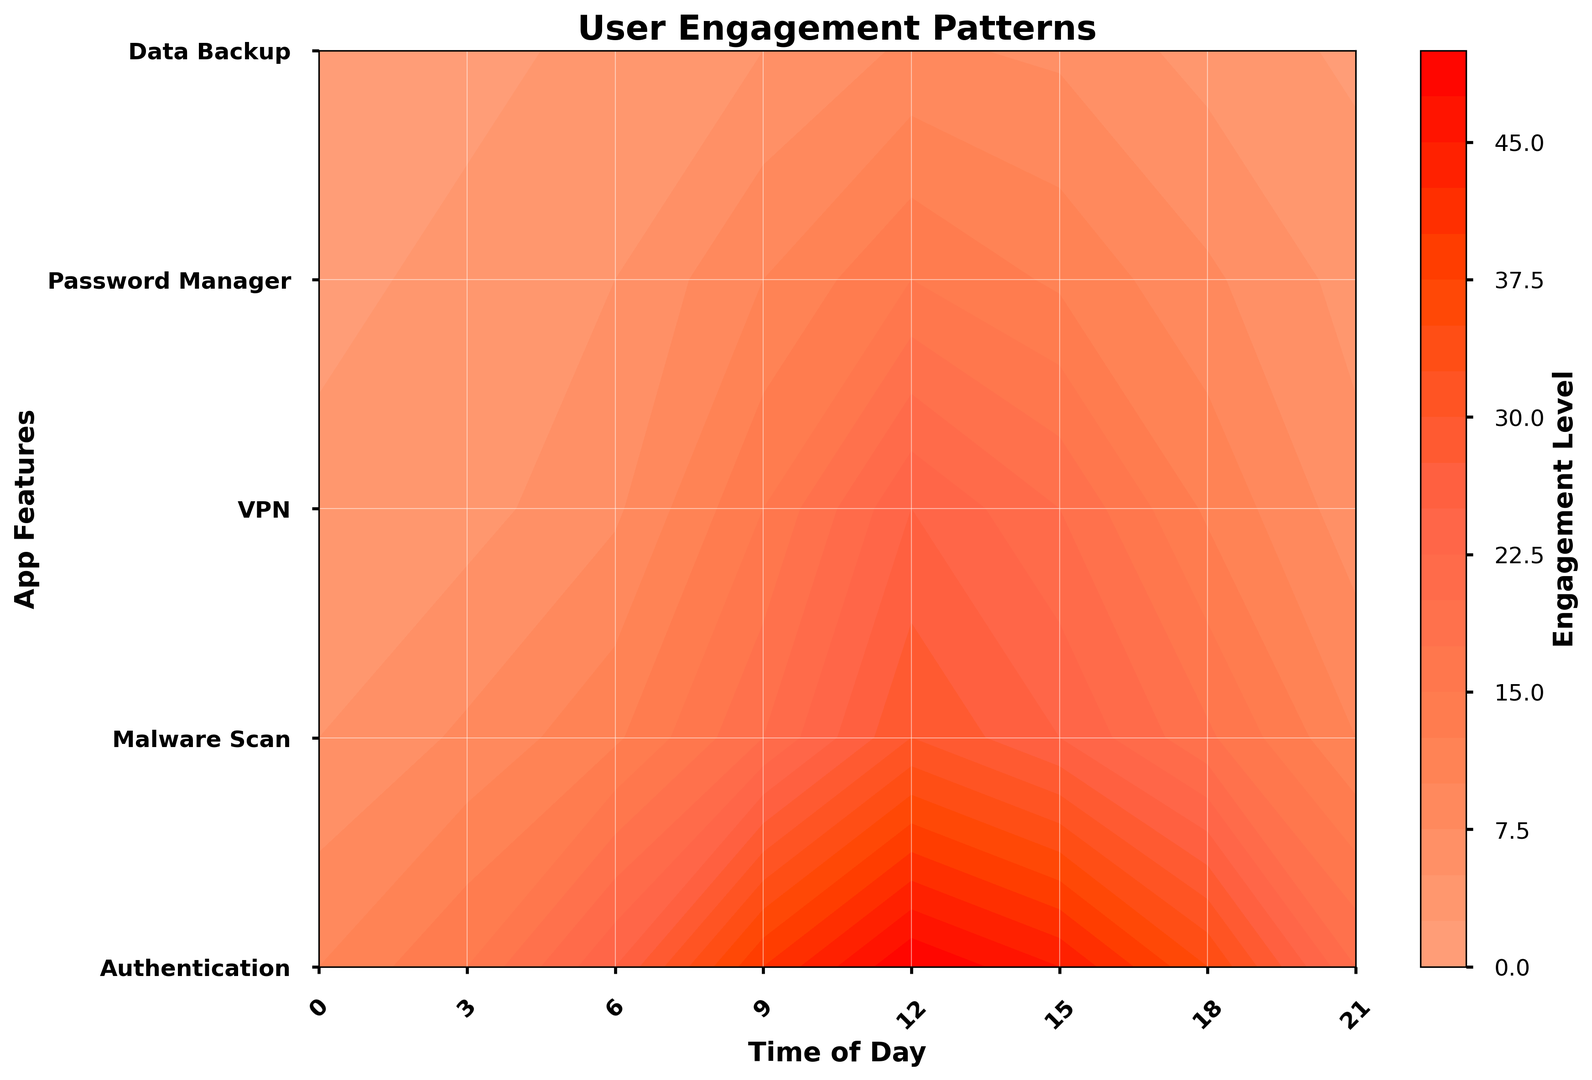What time of the day shows the highest user engagement for the Authentication feature? First, identify the contour levels or colors associated with the Authentication feature on the y-axis. Next, follow the contour pattern to find when engagement is at its peak. The highest value is achieved at the 12th hour (noon).
Answer: 12 PM When do the Malware Scan and VPN features both show their highest engagement levels during the day? Focus on the contour levels for both Malware Scan and VPN features separately across the time axis. The highest values can be seen at the 12th hour (noon) for both features when the contours display the deepest colors.
Answer: 12 PM Which feature has the least user engagement at 6 AM? Look at the contour levels at the 6 AM mark and check the engagement levels for all features. The lowest contour or color (least user engagement) corresponds to the Data Backup feature at this time.
Answer: Data Backup Compare the user engagement for the Password Manager feature between 9 AM and 3 PM. Which time shows higher engagement? Find Password Manager on the y-axis and then compare the contour levels at 9 AM and 3 PM. Engagement levels are higher at 9 AM where the contours show more intense color than those at 3 PM.
Answer: 9 AM How does user engagement for Data Backup change from 12 PM to 9 PM? Observe the contour levels or colors for the Data Backup feature on the y-axis at 12 PM and 9 PM. Engagement decreases from a mid-range at 12 PM to a lower range at 9 PM.
Answer: Decreases Is the user engagement for Authentication consistently higher than for VPN throughout the day? Compare the intensity of contour colors for Authentication and VPN across all time points (0, 3, 6, 9, 12, 15, 18, 21). Authentication shows consistently higher engagement with more intense contour levels throughout the whole day.
Answer: Yes What is the average engagement for the Malware Scan feature at 0 AM, 6 AM, and 12 PM? Identify the contour levels for Malware Scan at 0 AM, 6 AM, and 12 PM. These levels are 5, 12, and 30 respectively. Sum them up (5 + 12 + 30 = 47) and then divide by 3 to find the average (47/3 ≈ 15.67).
Answer: 15.67 Are there any times of the day when the engagement for any feature is higher than 40? If yes, which feature and when? Scan through the contour levels for all features across the entire time axis for any values exceeding the 40 mark. The Authentication feature at 9 AM and 12 PM shows engagement levels higher than 40.
Answer: Authentication at 9 AM and 12 PM Which feature shows a sharp increase in user engagement between 6 AM and 9 AM? Look at the contour gradient between 6 AM and 9 AM across all features. The sharpest increase, indicated by a steep rise in contour levels, is seen in the Authentication feature.
Answer: Authentication What is the combined engagement for VPN and Password Manager at 12 PM? Identify the contour levels for VPN and Password Manager at 12 PM, which are 25 and 15 respectively. Sum these values (25 + 15 = 40) to get the combined engagement.
Answer: 40 